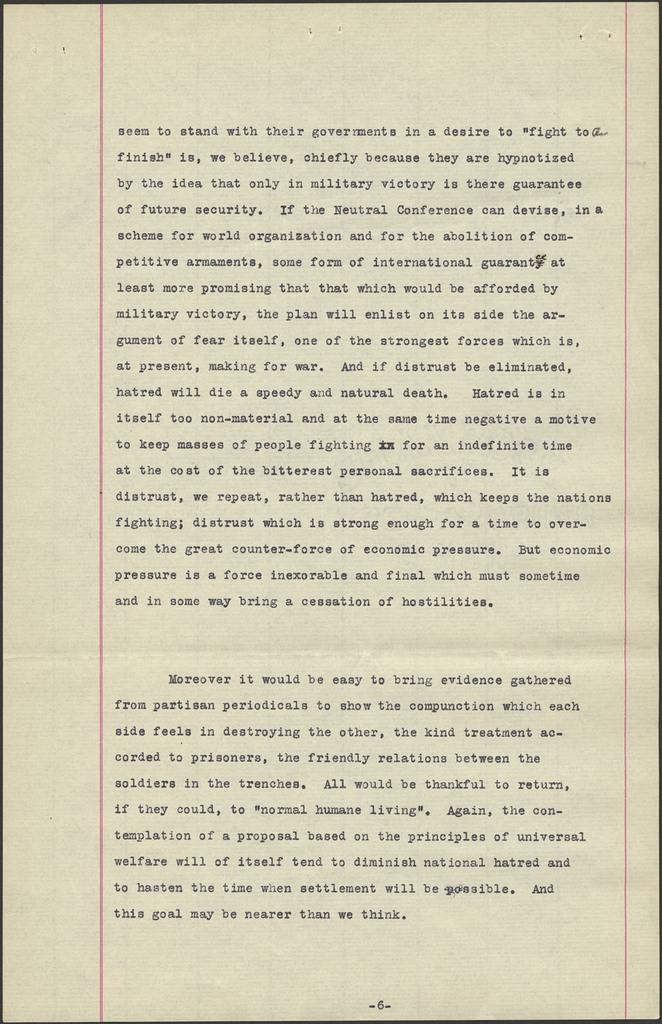<image>
Present a compact description of the photo's key features. A letter explaining about military victims and prisoners. 